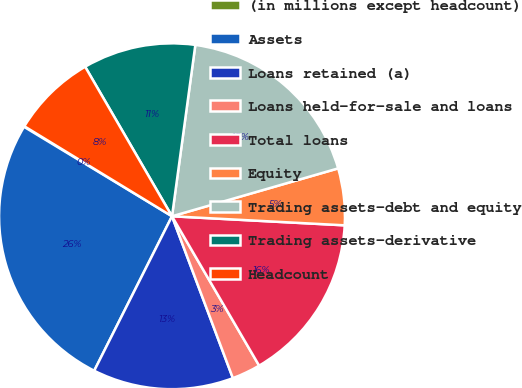Convert chart. <chart><loc_0><loc_0><loc_500><loc_500><pie_chart><fcel>(in millions except headcount)<fcel>Assets<fcel>Loans retained (a)<fcel>Loans held-for-sale and loans<fcel>Total loans<fcel>Equity<fcel>Trading assets-debt and equity<fcel>Trading assets-derivative<fcel>Headcount<nl><fcel>0.06%<fcel>26.23%<fcel>13.15%<fcel>2.68%<fcel>15.76%<fcel>5.3%<fcel>18.38%<fcel>10.53%<fcel>7.91%<nl></chart> 